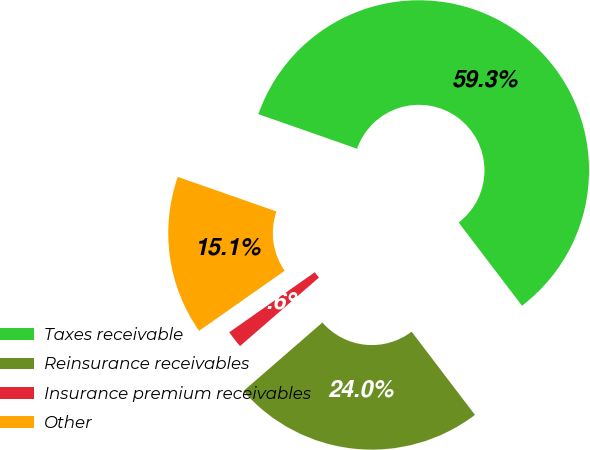Convert chart. <chart><loc_0><loc_0><loc_500><loc_500><pie_chart><fcel>Taxes receivable<fcel>Reinsurance receivables<fcel>Insurance premium receivables<fcel>Other<nl><fcel>59.29%<fcel>23.98%<fcel>1.64%<fcel>15.1%<nl></chart> 